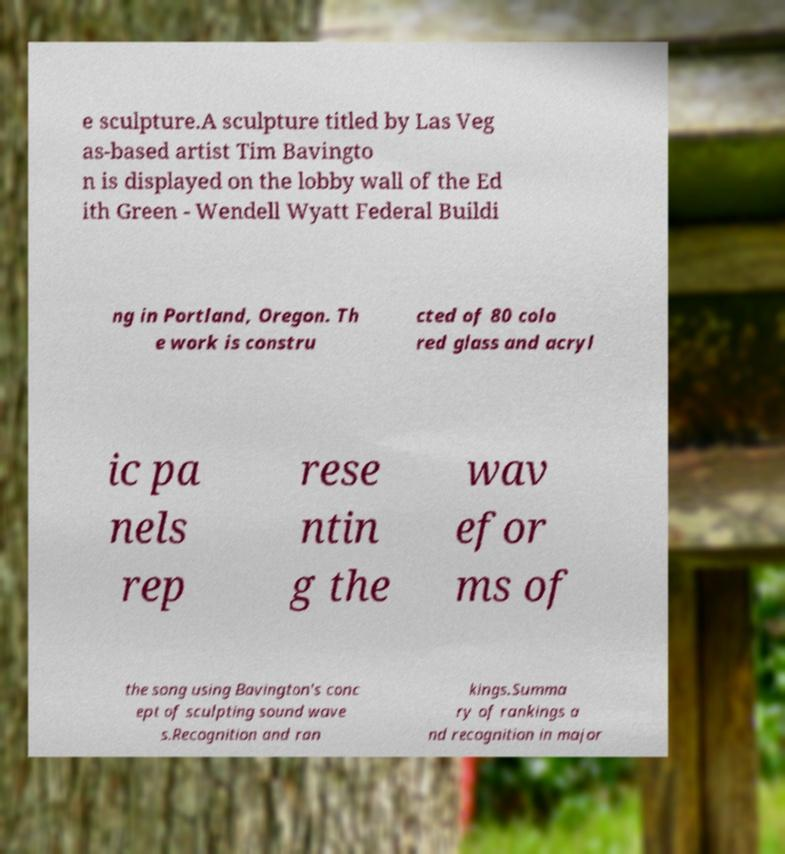Please read and relay the text visible in this image. What does it say? e sculpture.A sculpture titled by Las Veg as-based artist Tim Bavingto n is displayed on the lobby wall of the Ed ith Green - Wendell Wyatt Federal Buildi ng in Portland, Oregon. Th e work is constru cted of 80 colo red glass and acryl ic pa nels rep rese ntin g the wav efor ms of the song using Bavington's conc ept of sculpting sound wave s.Recognition and ran kings.Summa ry of rankings a nd recognition in major 